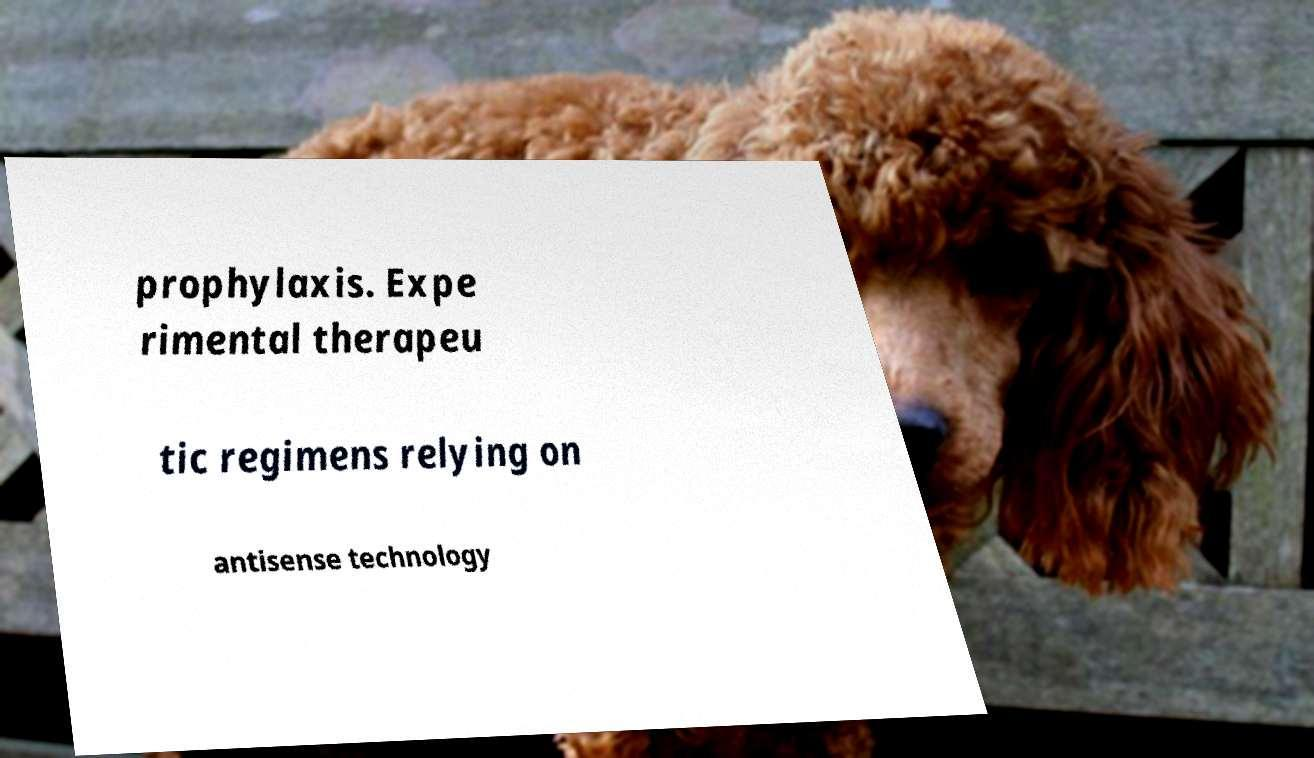Can you read and provide the text displayed in the image?This photo seems to have some interesting text. Can you extract and type it out for me? prophylaxis. Expe rimental therapeu tic regimens relying on antisense technology 